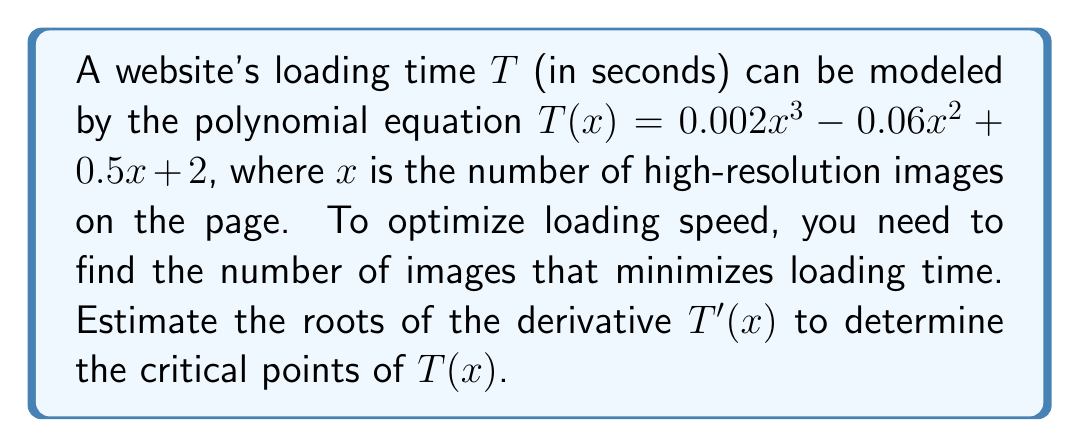Give your solution to this math problem. To find the critical points of $T(x)$, we need to find the roots of its derivative $T'(x)$. Let's follow these steps:

1) First, let's find $T'(x)$:
   $$T'(x) = 0.006x^2 - 0.12x + 0.5$$

2) This is a quadratic equation. To find its roots, we can use the quadratic formula:
   $$x = \frac{-b \pm \sqrt{b^2 - 4ac}}{2a}$$
   where $a = 0.006$, $b = -0.12$, and $c = 0.5$

3) Let's calculate the discriminant:
   $$b^2 - 4ac = (-0.12)^2 - 4(0.006)(0.5) = 0.0144 - 0.012 = 0.0024$$

4) Now we can plug this into the quadratic formula:
   $$x = \frac{0.12 \pm \sqrt{0.0024}}{0.012}$$

5) Simplifying:
   $$x = \frac{0.12 \pm 0.049}{0.012}$$

6) This gives us two solutions:
   $$x_1 \approx \frac{0.12 + 0.049}{0.012} \approx 14.08$$
   $$x_2 \approx \frac{0.12 - 0.049}{0.012} \approx 5.92$$

Therefore, the critical points of $T(x)$ occur when $x$ is approximately 6 and 14.
Answer: The roots of $T'(x)$ are approximately 6 and 14. 